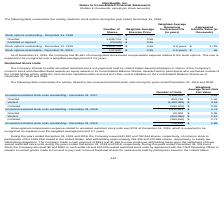From Nanthealth's financial document, What are the respective number of units granted and vested in 2017? The document shows two values: 853,736 and 1,583,399. From the document: "Vested (1,583,399) $ 3.18 Granted 853,736 $ 1.46..." Also, What are the respective number of units granted and vested in 2018? The document shows two values: 60,000 and 904,096. From the document: "Vested (904,096) $ 2.67 Granted 60,000 $ 0.98..." Also, What are the respective number of units forfeited in 2017 and 2018? The document shows two values: 563,400 and 263,450. From the document: "Forfeited (563,400) $ 3.39 Forfeited (263,450) $ 2.71..." Also, can you calculate: What is the average number of units granted in 2017 and 2018? To answer this question, I need to perform calculations using the financial data. The calculation is: (853,736 + 60,000)/2 , which equals 456868. This is based on the information: "Granted 853,736 $ 1.46 Granted 60,000 $ 0.98..." The key data points involved are: 60,000, 853,736. Also, can you calculate: What is the average number of units vested in 2017 and 2018? To answer this question, I need to perform calculations using the financial data. The calculation is: (1,583,399 + 904,096)/2 , which equals 1243747.5. This is based on the information: "Vested (1,583,399) $ 3.18 Vested (904,096) $ 2.67..." The key data points involved are: 1,583,399, 904,096. Also, can you calculate: What is the average number of units forfeited in 2017 and 2018? To answer this question, I need to perform calculations using the financial data. The calculation is: (563,400 + 263,450)/2 , which equals 413425. This is based on the information: "Forfeited (563,400) $ 3.39 Forfeited (263,450) $ 2.71..." The key data points involved are: 263,450, 563,400. 